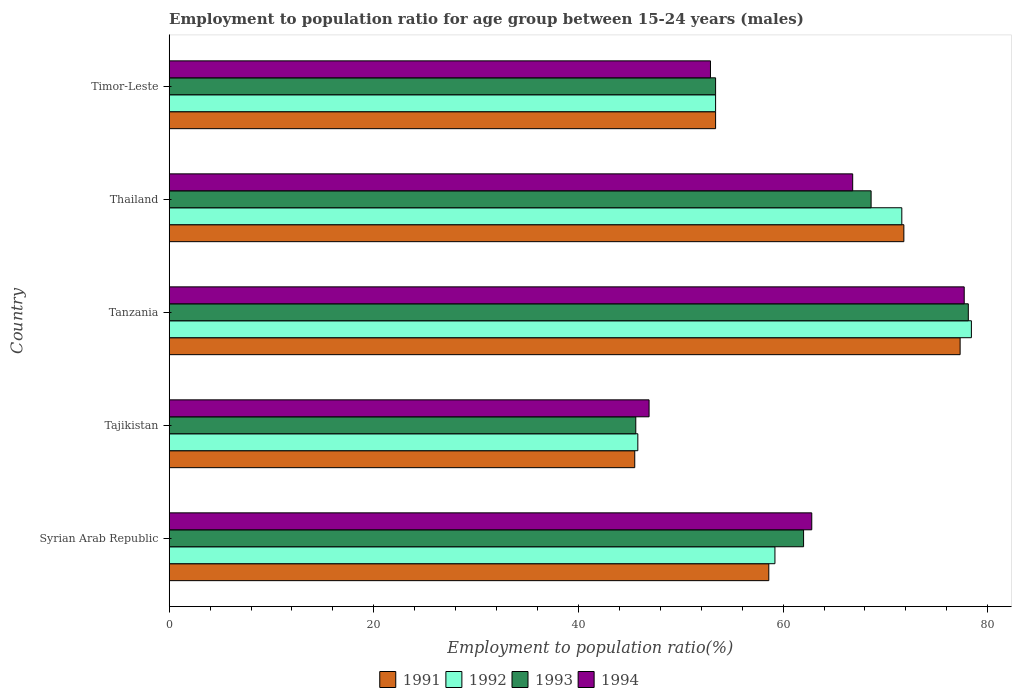How many different coloured bars are there?
Your response must be concise. 4. How many groups of bars are there?
Make the answer very short. 5. Are the number of bars per tick equal to the number of legend labels?
Make the answer very short. Yes. How many bars are there on the 1st tick from the bottom?
Give a very brief answer. 4. What is the label of the 5th group of bars from the top?
Your answer should be very brief. Syrian Arab Republic. What is the employment to population ratio in 1994 in Syrian Arab Republic?
Your answer should be very brief. 62.8. Across all countries, what is the maximum employment to population ratio in 1993?
Keep it short and to the point. 78.1. Across all countries, what is the minimum employment to population ratio in 1994?
Ensure brevity in your answer.  46.9. In which country was the employment to population ratio in 1992 maximum?
Your answer should be compact. Tanzania. In which country was the employment to population ratio in 1993 minimum?
Give a very brief answer. Tajikistan. What is the total employment to population ratio in 1991 in the graph?
Offer a terse response. 306.6. What is the difference between the employment to population ratio in 1994 in Thailand and that in Timor-Leste?
Provide a succinct answer. 13.9. What is the difference between the employment to population ratio in 1991 in Tajikistan and the employment to population ratio in 1993 in Thailand?
Your answer should be compact. -23.1. What is the average employment to population ratio in 1993 per country?
Offer a terse response. 61.54. What is the difference between the employment to population ratio in 1994 and employment to population ratio in 1993 in Thailand?
Your response must be concise. -1.8. What is the ratio of the employment to population ratio in 1992 in Syrian Arab Republic to that in Tajikistan?
Give a very brief answer. 1.29. Is the difference between the employment to population ratio in 1994 in Tajikistan and Tanzania greater than the difference between the employment to population ratio in 1993 in Tajikistan and Tanzania?
Offer a very short reply. Yes. What is the difference between the highest and the second highest employment to population ratio in 1991?
Your answer should be compact. 5.5. What is the difference between the highest and the lowest employment to population ratio in 1991?
Offer a very short reply. 31.8. Is it the case that in every country, the sum of the employment to population ratio in 1991 and employment to population ratio in 1992 is greater than the sum of employment to population ratio in 1993 and employment to population ratio in 1994?
Give a very brief answer. No. What does the 2nd bar from the bottom in Timor-Leste represents?
Make the answer very short. 1992. Are all the bars in the graph horizontal?
Make the answer very short. Yes. How many countries are there in the graph?
Offer a very short reply. 5. Are the values on the major ticks of X-axis written in scientific E-notation?
Your response must be concise. No. Does the graph contain any zero values?
Provide a short and direct response. No. Where does the legend appear in the graph?
Your response must be concise. Bottom center. How many legend labels are there?
Keep it short and to the point. 4. How are the legend labels stacked?
Provide a short and direct response. Horizontal. What is the title of the graph?
Provide a succinct answer. Employment to population ratio for age group between 15-24 years (males). What is the label or title of the X-axis?
Offer a very short reply. Employment to population ratio(%). What is the label or title of the Y-axis?
Your response must be concise. Country. What is the Employment to population ratio(%) in 1991 in Syrian Arab Republic?
Provide a short and direct response. 58.6. What is the Employment to population ratio(%) of 1992 in Syrian Arab Republic?
Give a very brief answer. 59.2. What is the Employment to population ratio(%) in 1993 in Syrian Arab Republic?
Ensure brevity in your answer.  62. What is the Employment to population ratio(%) of 1994 in Syrian Arab Republic?
Offer a terse response. 62.8. What is the Employment to population ratio(%) of 1991 in Tajikistan?
Your response must be concise. 45.5. What is the Employment to population ratio(%) of 1992 in Tajikistan?
Offer a very short reply. 45.8. What is the Employment to population ratio(%) of 1993 in Tajikistan?
Your answer should be very brief. 45.6. What is the Employment to population ratio(%) of 1994 in Tajikistan?
Your answer should be compact. 46.9. What is the Employment to population ratio(%) in 1991 in Tanzania?
Provide a succinct answer. 77.3. What is the Employment to population ratio(%) in 1992 in Tanzania?
Provide a succinct answer. 78.4. What is the Employment to population ratio(%) of 1993 in Tanzania?
Ensure brevity in your answer.  78.1. What is the Employment to population ratio(%) in 1994 in Tanzania?
Offer a terse response. 77.7. What is the Employment to population ratio(%) of 1991 in Thailand?
Keep it short and to the point. 71.8. What is the Employment to population ratio(%) of 1992 in Thailand?
Give a very brief answer. 71.6. What is the Employment to population ratio(%) in 1993 in Thailand?
Your answer should be very brief. 68.6. What is the Employment to population ratio(%) of 1994 in Thailand?
Provide a succinct answer. 66.8. What is the Employment to population ratio(%) of 1991 in Timor-Leste?
Make the answer very short. 53.4. What is the Employment to population ratio(%) in 1992 in Timor-Leste?
Offer a very short reply. 53.4. What is the Employment to population ratio(%) in 1993 in Timor-Leste?
Offer a terse response. 53.4. What is the Employment to population ratio(%) in 1994 in Timor-Leste?
Provide a succinct answer. 52.9. Across all countries, what is the maximum Employment to population ratio(%) in 1991?
Give a very brief answer. 77.3. Across all countries, what is the maximum Employment to population ratio(%) of 1992?
Keep it short and to the point. 78.4. Across all countries, what is the maximum Employment to population ratio(%) in 1993?
Your answer should be very brief. 78.1. Across all countries, what is the maximum Employment to population ratio(%) of 1994?
Your response must be concise. 77.7. Across all countries, what is the minimum Employment to population ratio(%) of 1991?
Offer a terse response. 45.5. Across all countries, what is the minimum Employment to population ratio(%) of 1992?
Your answer should be compact. 45.8. Across all countries, what is the minimum Employment to population ratio(%) of 1993?
Offer a very short reply. 45.6. Across all countries, what is the minimum Employment to population ratio(%) in 1994?
Provide a succinct answer. 46.9. What is the total Employment to population ratio(%) of 1991 in the graph?
Offer a terse response. 306.6. What is the total Employment to population ratio(%) of 1992 in the graph?
Give a very brief answer. 308.4. What is the total Employment to population ratio(%) in 1993 in the graph?
Keep it short and to the point. 307.7. What is the total Employment to population ratio(%) in 1994 in the graph?
Give a very brief answer. 307.1. What is the difference between the Employment to population ratio(%) in 1991 in Syrian Arab Republic and that in Tajikistan?
Provide a short and direct response. 13.1. What is the difference between the Employment to population ratio(%) of 1993 in Syrian Arab Republic and that in Tajikistan?
Provide a short and direct response. 16.4. What is the difference between the Employment to population ratio(%) of 1991 in Syrian Arab Republic and that in Tanzania?
Make the answer very short. -18.7. What is the difference between the Employment to population ratio(%) in 1992 in Syrian Arab Republic and that in Tanzania?
Offer a very short reply. -19.2. What is the difference between the Employment to population ratio(%) in 1993 in Syrian Arab Republic and that in Tanzania?
Your answer should be compact. -16.1. What is the difference between the Employment to population ratio(%) in 1994 in Syrian Arab Republic and that in Tanzania?
Your response must be concise. -14.9. What is the difference between the Employment to population ratio(%) in 1991 in Syrian Arab Republic and that in Thailand?
Your response must be concise. -13.2. What is the difference between the Employment to population ratio(%) of 1993 in Syrian Arab Republic and that in Thailand?
Offer a very short reply. -6.6. What is the difference between the Employment to population ratio(%) in 1994 in Syrian Arab Republic and that in Thailand?
Make the answer very short. -4. What is the difference between the Employment to population ratio(%) of 1991 in Syrian Arab Republic and that in Timor-Leste?
Provide a succinct answer. 5.2. What is the difference between the Employment to population ratio(%) of 1992 in Syrian Arab Republic and that in Timor-Leste?
Offer a terse response. 5.8. What is the difference between the Employment to population ratio(%) of 1993 in Syrian Arab Republic and that in Timor-Leste?
Ensure brevity in your answer.  8.6. What is the difference between the Employment to population ratio(%) in 1994 in Syrian Arab Republic and that in Timor-Leste?
Your answer should be very brief. 9.9. What is the difference between the Employment to population ratio(%) in 1991 in Tajikistan and that in Tanzania?
Make the answer very short. -31.8. What is the difference between the Employment to population ratio(%) in 1992 in Tajikistan and that in Tanzania?
Provide a succinct answer. -32.6. What is the difference between the Employment to population ratio(%) in 1993 in Tajikistan and that in Tanzania?
Provide a short and direct response. -32.5. What is the difference between the Employment to population ratio(%) in 1994 in Tajikistan and that in Tanzania?
Provide a short and direct response. -30.8. What is the difference between the Employment to population ratio(%) in 1991 in Tajikistan and that in Thailand?
Your answer should be very brief. -26.3. What is the difference between the Employment to population ratio(%) of 1992 in Tajikistan and that in Thailand?
Keep it short and to the point. -25.8. What is the difference between the Employment to population ratio(%) in 1993 in Tajikistan and that in Thailand?
Offer a very short reply. -23. What is the difference between the Employment to population ratio(%) of 1994 in Tajikistan and that in Thailand?
Provide a short and direct response. -19.9. What is the difference between the Employment to population ratio(%) of 1994 in Tajikistan and that in Timor-Leste?
Keep it short and to the point. -6. What is the difference between the Employment to population ratio(%) in 1992 in Tanzania and that in Thailand?
Offer a very short reply. 6.8. What is the difference between the Employment to population ratio(%) in 1994 in Tanzania and that in Thailand?
Offer a terse response. 10.9. What is the difference between the Employment to population ratio(%) in 1991 in Tanzania and that in Timor-Leste?
Ensure brevity in your answer.  23.9. What is the difference between the Employment to population ratio(%) of 1993 in Tanzania and that in Timor-Leste?
Ensure brevity in your answer.  24.7. What is the difference between the Employment to population ratio(%) of 1994 in Tanzania and that in Timor-Leste?
Your answer should be very brief. 24.8. What is the difference between the Employment to population ratio(%) of 1991 in Thailand and that in Timor-Leste?
Your response must be concise. 18.4. What is the difference between the Employment to population ratio(%) of 1994 in Thailand and that in Timor-Leste?
Offer a very short reply. 13.9. What is the difference between the Employment to population ratio(%) of 1991 in Syrian Arab Republic and the Employment to population ratio(%) of 1993 in Tajikistan?
Your answer should be compact. 13. What is the difference between the Employment to population ratio(%) of 1991 in Syrian Arab Republic and the Employment to population ratio(%) of 1994 in Tajikistan?
Your response must be concise. 11.7. What is the difference between the Employment to population ratio(%) of 1992 in Syrian Arab Republic and the Employment to population ratio(%) of 1994 in Tajikistan?
Provide a short and direct response. 12.3. What is the difference between the Employment to population ratio(%) of 1993 in Syrian Arab Republic and the Employment to population ratio(%) of 1994 in Tajikistan?
Ensure brevity in your answer.  15.1. What is the difference between the Employment to population ratio(%) of 1991 in Syrian Arab Republic and the Employment to population ratio(%) of 1992 in Tanzania?
Offer a terse response. -19.8. What is the difference between the Employment to population ratio(%) in 1991 in Syrian Arab Republic and the Employment to population ratio(%) in 1993 in Tanzania?
Keep it short and to the point. -19.5. What is the difference between the Employment to population ratio(%) of 1991 in Syrian Arab Republic and the Employment to population ratio(%) of 1994 in Tanzania?
Ensure brevity in your answer.  -19.1. What is the difference between the Employment to population ratio(%) of 1992 in Syrian Arab Republic and the Employment to population ratio(%) of 1993 in Tanzania?
Your response must be concise. -18.9. What is the difference between the Employment to population ratio(%) in 1992 in Syrian Arab Republic and the Employment to population ratio(%) in 1994 in Tanzania?
Keep it short and to the point. -18.5. What is the difference between the Employment to population ratio(%) in 1993 in Syrian Arab Republic and the Employment to population ratio(%) in 1994 in Tanzania?
Keep it short and to the point. -15.7. What is the difference between the Employment to population ratio(%) of 1991 in Syrian Arab Republic and the Employment to population ratio(%) of 1993 in Thailand?
Keep it short and to the point. -10. What is the difference between the Employment to population ratio(%) of 1991 in Syrian Arab Republic and the Employment to population ratio(%) of 1994 in Thailand?
Your answer should be compact. -8.2. What is the difference between the Employment to population ratio(%) in 1992 in Syrian Arab Republic and the Employment to population ratio(%) in 1994 in Thailand?
Ensure brevity in your answer.  -7.6. What is the difference between the Employment to population ratio(%) of 1991 in Syrian Arab Republic and the Employment to population ratio(%) of 1993 in Timor-Leste?
Offer a very short reply. 5.2. What is the difference between the Employment to population ratio(%) of 1992 in Syrian Arab Republic and the Employment to population ratio(%) of 1993 in Timor-Leste?
Offer a terse response. 5.8. What is the difference between the Employment to population ratio(%) of 1992 in Syrian Arab Republic and the Employment to population ratio(%) of 1994 in Timor-Leste?
Your answer should be compact. 6.3. What is the difference between the Employment to population ratio(%) of 1991 in Tajikistan and the Employment to population ratio(%) of 1992 in Tanzania?
Offer a terse response. -32.9. What is the difference between the Employment to population ratio(%) in 1991 in Tajikistan and the Employment to population ratio(%) in 1993 in Tanzania?
Give a very brief answer. -32.6. What is the difference between the Employment to population ratio(%) in 1991 in Tajikistan and the Employment to population ratio(%) in 1994 in Tanzania?
Your answer should be compact. -32.2. What is the difference between the Employment to population ratio(%) of 1992 in Tajikistan and the Employment to population ratio(%) of 1993 in Tanzania?
Offer a very short reply. -32.3. What is the difference between the Employment to population ratio(%) of 1992 in Tajikistan and the Employment to population ratio(%) of 1994 in Tanzania?
Ensure brevity in your answer.  -31.9. What is the difference between the Employment to population ratio(%) in 1993 in Tajikistan and the Employment to population ratio(%) in 1994 in Tanzania?
Give a very brief answer. -32.1. What is the difference between the Employment to population ratio(%) in 1991 in Tajikistan and the Employment to population ratio(%) in 1992 in Thailand?
Provide a succinct answer. -26.1. What is the difference between the Employment to population ratio(%) in 1991 in Tajikistan and the Employment to population ratio(%) in 1993 in Thailand?
Your response must be concise. -23.1. What is the difference between the Employment to population ratio(%) in 1991 in Tajikistan and the Employment to population ratio(%) in 1994 in Thailand?
Your answer should be compact. -21.3. What is the difference between the Employment to population ratio(%) of 1992 in Tajikistan and the Employment to population ratio(%) of 1993 in Thailand?
Your answer should be very brief. -22.8. What is the difference between the Employment to population ratio(%) in 1993 in Tajikistan and the Employment to population ratio(%) in 1994 in Thailand?
Offer a very short reply. -21.2. What is the difference between the Employment to population ratio(%) of 1992 in Tajikistan and the Employment to population ratio(%) of 1993 in Timor-Leste?
Keep it short and to the point. -7.6. What is the difference between the Employment to population ratio(%) of 1992 in Tajikistan and the Employment to population ratio(%) of 1994 in Timor-Leste?
Provide a short and direct response. -7.1. What is the difference between the Employment to population ratio(%) of 1991 in Tanzania and the Employment to population ratio(%) of 1992 in Thailand?
Offer a very short reply. 5.7. What is the difference between the Employment to population ratio(%) in 1991 in Tanzania and the Employment to population ratio(%) in 1993 in Thailand?
Your response must be concise. 8.7. What is the difference between the Employment to population ratio(%) in 1991 in Tanzania and the Employment to population ratio(%) in 1994 in Thailand?
Your answer should be very brief. 10.5. What is the difference between the Employment to population ratio(%) in 1992 in Tanzania and the Employment to population ratio(%) in 1993 in Thailand?
Ensure brevity in your answer.  9.8. What is the difference between the Employment to population ratio(%) in 1993 in Tanzania and the Employment to population ratio(%) in 1994 in Thailand?
Your answer should be compact. 11.3. What is the difference between the Employment to population ratio(%) of 1991 in Tanzania and the Employment to population ratio(%) of 1992 in Timor-Leste?
Provide a short and direct response. 23.9. What is the difference between the Employment to population ratio(%) of 1991 in Tanzania and the Employment to population ratio(%) of 1993 in Timor-Leste?
Provide a succinct answer. 23.9. What is the difference between the Employment to population ratio(%) in 1991 in Tanzania and the Employment to population ratio(%) in 1994 in Timor-Leste?
Offer a terse response. 24.4. What is the difference between the Employment to population ratio(%) of 1992 in Tanzania and the Employment to population ratio(%) of 1993 in Timor-Leste?
Provide a succinct answer. 25. What is the difference between the Employment to population ratio(%) of 1992 in Tanzania and the Employment to population ratio(%) of 1994 in Timor-Leste?
Give a very brief answer. 25.5. What is the difference between the Employment to population ratio(%) in 1993 in Tanzania and the Employment to population ratio(%) in 1994 in Timor-Leste?
Keep it short and to the point. 25.2. What is the difference between the Employment to population ratio(%) of 1991 in Thailand and the Employment to population ratio(%) of 1992 in Timor-Leste?
Your response must be concise. 18.4. What is the difference between the Employment to population ratio(%) of 1991 in Thailand and the Employment to population ratio(%) of 1993 in Timor-Leste?
Your response must be concise. 18.4. What is the difference between the Employment to population ratio(%) of 1991 in Thailand and the Employment to population ratio(%) of 1994 in Timor-Leste?
Give a very brief answer. 18.9. What is the difference between the Employment to population ratio(%) of 1992 in Thailand and the Employment to population ratio(%) of 1993 in Timor-Leste?
Ensure brevity in your answer.  18.2. What is the difference between the Employment to population ratio(%) in 1992 in Thailand and the Employment to population ratio(%) in 1994 in Timor-Leste?
Provide a succinct answer. 18.7. What is the difference between the Employment to population ratio(%) in 1993 in Thailand and the Employment to population ratio(%) in 1994 in Timor-Leste?
Provide a short and direct response. 15.7. What is the average Employment to population ratio(%) of 1991 per country?
Keep it short and to the point. 61.32. What is the average Employment to population ratio(%) of 1992 per country?
Provide a succinct answer. 61.68. What is the average Employment to population ratio(%) of 1993 per country?
Your response must be concise. 61.54. What is the average Employment to population ratio(%) in 1994 per country?
Your answer should be compact. 61.42. What is the difference between the Employment to population ratio(%) in 1991 and Employment to population ratio(%) in 1992 in Syrian Arab Republic?
Your answer should be very brief. -0.6. What is the difference between the Employment to population ratio(%) of 1992 and Employment to population ratio(%) of 1993 in Syrian Arab Republic?
Your response must be concise. -2.8. What is the difference between the Employment to population ratio(%) in 1993 and Employment to population ratio(%) in 1994 in Syrian Arab Republic?
Offer a terse response. -0.8. What is the difference between the Employment to population ratio(%) in 1991 and Employment to population ratio(%) in 1992 in Tajikistan?
Ensure brevity in your answer.  -0.3. What is the difference between the Employment to population ratio(%) of 1991 and Employment to population ratio(%) of 1993 in Tajikistan?
Provide a succinct answer. -0.1. What is the difference between the Employment to population ratio(%) of 1991 and Employment to population ratio(%) of 1994 in Tajikistan?
Your response must be concise. -1.4. What is the difference between the Employment to population ratio(%) of 1992 and Employment to population ratio(%) of 1993 in Tajikistan?
Your answer should be very brief. 0.2. What is the difference between the Employment to population ratio(%) in 1992 and Employment to population ratio(%) in 1994 in Tajikistan?
Offer a terse response. -1.1. What is the difference between the Employment to population ratio(%) of 1991 and Employment to population ratio(%) of 1992 in Tanzania?
Offer a terse response. -1.1. What is the difference between the Employment to population ratio(%) in 1991 and Employment to population ratio(%) in 1993 in Tanzania?
Your answer should be compact. -0.8. What is the difference between the Employment to population ratio(%) in 1992 and Employment to population ratio(%) in 1994 in Tanzania?
Keep it short and to the point. 0.7. What is the difference between the Employment to population ratio(%) in 1993 and Employment to population ratio(%) in 1994 in Thailand?
Your answer should be very brief. 1.8. What is the difference between the Employment to population ratio(%) of 1991 and Employment to population ratio(%) of 1993 in Timor-Leste?
Offer a very short reply. 0. What is the difference between the Employment to population ratio(%) in 1991 and Employment to population ratio(%) in 1994 in Timor-Leste?
Your response must be concise. 0.5. What is the difference between the Employment to population ratio(%) in 1993 and Employment to population ratio(%) in 1994 in Timor-Leste?
Your response must be concise. 0.5. What is the ratio of the Employment to population ratio(%) in 1991 in Syrian Arab Republic to that in Tajikistan?
Your answer should be very brief. 1.29. What is the ratio of the Employment to population ratio(%) of 1992 in Syrian Arab Republic to that in Tajikistan?
Your response must be concise. 1.29. What is the ratio of the Employment to population ratio(%) of 1993 in Syrian Arab Republic to that in Tajikistan?
Your answer should be compact. 1.36. What is the ratio of the Employment to population ratio(%) of 1994 in Syrian Arab Republic to that in Tajikistan?
Make the answer very short. 1.34. What is the ratio of the Employment to population ratio(%) of 1991 in Syrian Arab Republic to that in Tanzania?
Your answer should be very brief. 0.76. What is the ratio of the Employment to population ratio(%) of 1992 in Syrian Arab Republic to that in Tanzania?
Give a very brief answer. 0.76. What is the ratio of the Employment to population ratio(%) in 1993 in Syrian Arab Republic to that in Tanzania?
Your answer should be very brief. 0.79. What is the ratio of the Employment to population ratio(%) in 1994 in Syrian Arab Republic to that in Tanzania?
Ensure brevity in your answer.  0.81. What is the ratio of the Employment to population ratio(%) of 1991 in Syrian Arab Republic to that in Thailand?
Ensure brevity in your answer.  0.82. What is the ratio of the Employment to population ratio(%) in 1992 in Syrian Arab Republic to that in Thailand?
Offer a very short reply. 0.83. What is the ratio of the Employment to population ratio(%) of 1993 in Syrian Arab Republic to that in Thailand?
Your answer should be very brief. 0.9. What is the ratio of the Employment to population ratio(%) in 1994 in Syrian Arab Republic to that in Thailand?
Your response must be concise. 0.94. What is the ratio of the Employment to population ratio(%) in 1991 in Syrian Arab Republic to that in Timor-Leste?
Provide a succinct answer. 1.1. What is the ratio of the Employment to population ratio(%) of 1992 in Syrian Arab Republic to that in Timor-Leste?
Your answer should be compact. 1.11. What is the ratio of the Employment to population ratio(%) of 1993 in Syrian Arab Republic to that in Timor-Leste?
Provide a short and direct response. 1.16. What is the ratio of the Employment to population ratio(%) in 1994 in Syrian Arab Republic to that in Timor-Leste?
Keep it short and to the point. 1.19. What is the ratio of the Employment to population ratio(%) in 1991 in Tajikistan to that in Tanzania?
Ensure brevity in your answer.  0.59. What is the ratio of the Employment to population ratio(%) in 1992 in Tajikistan to that in Tanzania?
Your answer should be very brief. 0.58. What is the ratio of the Employment to population ratio(%) in 1993 in Tajikistan to that in Tanzania?
Your answer should be very brief. 0.58. What is the ratio of the Employment to population ratio(%) in 1994 in Tajikistan to that in Tanzania?
Your response must be concise. 0.6. What is the ratio of the Employment to population ratio(%) in 1991 in Tajikistan to that in Thailand?
Your response must be concise. 0.63. What is the ratio of the Employment to population ratio(%) in 1992 in Tajikistan to that in Thailand?
Ensure brevity in your answer.  0.64. What is the ratio of the Employment to population ratio(%) in 1993 in Tajikistan to that in Thailand?
Your response must be concise. 0.66. What is the ratio of the Employment to population ratio(%) of 1994 in Tajikistan to that in Thailand?
Your answer should be very brief. 0.7. What is the ratio of the Employment to population ratio(%) in 1991 in Tajikistan to that in Timor-Leste?
Your answer should be compact. 0.85. What is the ratio of the Employment to population ratio(%) in 1992 in Tajikistan to that in Timor-Leste?
Offer a terse response. 0.86. What is the ratio of the Employment to population ratio(%) in 1993 in Tajikistan to that in Timor-Leste?
Your answer should be very brief. 0.85. What is the ratio of the Employment to population ratio(%) in 1994 in Tajikistan to that in Timor-Leste?
Your answer should be compact. 0.89. What is the ratio of the Employment to population ratio(%) in 1991 in Tanzania to that in Thailand?
Make the answer very short. 1.08. What is the ratio of the Employment to population ratio(%) of 1992 in Tanzania to that in Thailand?
Your answer should be compact. 1.09. What is the ratio of the Employment to population ratio(%) of 1993 in Tanzania to that in Thailand?
Make the answer very short. 1.14. What is the ratio of the Employment to population ratio(%) in 1994 in Tanzania to that in Thailand?
Offer a terse response. 1.16. What is the ratio of the Employment to population ratio(%) in 1991 in Tanzania to that in Timor-Leste?
Keep it short and to the point. 1.45. What is the ratio of the Employment to population ratio(%) of 1992 in Tanzania to that in Timor-Leste?
Your response must be concise. 1.47. What is the ratio of the Employment to population ratio(%) in 1993 in Tanzania to that in Timor-Leste?
Make the answer very short. 1.46. What is the ratio of the Employment to population ratio(%) in 1994 in Tanzania to that in Timor-Leste?
Your answer should be compact. 1.47. What is the ratio of the Employment to population ratio(%) in 1991 in Thailand to that in Timor-Leste?
Your answer should be compact. 1.34. What is the ratio of the Employment to population ratio(%) in 1992 in Thailand to that in Timor-Leste?
Ensure brevity in your answer.  1.34. What is the ratio of the Employment to population ratio(%) of 1993 in Thailand to that in Timor-Leste?
Give a very brief answer. 1.28. What is the ratio of the Employment to population ratio(%) of 1994 in Thailand to that in Timor-Leste?
Your answer should be compact. 1.26. What is the difference between the highest and the second highest Employment to population ratio(%) in 1991?
Your answer should be compact. 5.5. What is the difference between the highest and the second highest Employment to population ratio(%) in 1992?
Give a very brief answer. 6.8. What is the difference between the highest and the second highest Employment to population ratio(%) in 1993?
Your answer should be very brief. 9.5. What is the difference between the highest and the second highest Employment to population ratio(%) in 1994?
Offer a terse response. 10.9. What is the difference between the highest and the lowest Employment to population ratio(%) of 1991?
Ensure brevity in your answer.  31.8. What is the difference between the highest and the lowest Employment to population ratio(%) of 1992?
Your answer should be compact. 32.6. What is the difference between the highest and the lowest Employment to population ratio(%) in 1993?
Your response must be concise. 32.5. What is the difference between the highest and the lowest Employment to population ratio(%) in 1994?
Make the answer very short. 30.8. 